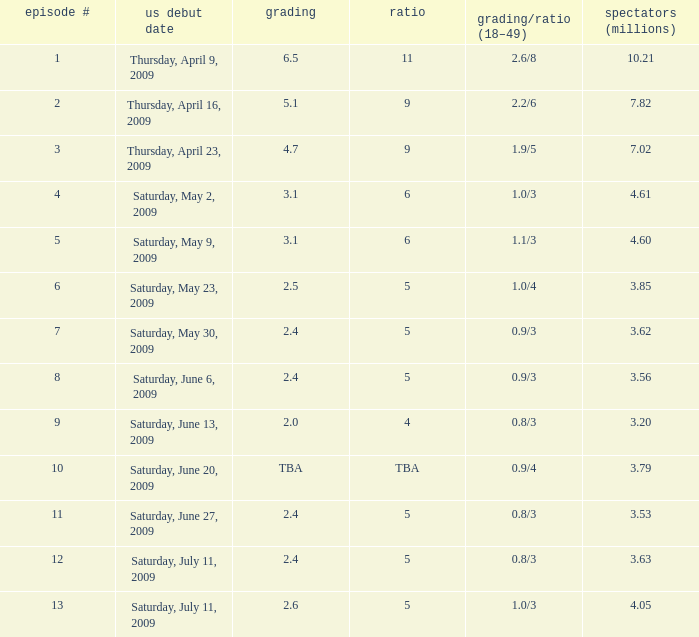Could you parse the entire table as a dict? {'header': ['episode #', 'us debut date', 'grading', 'ratio', 'grading/ratio (18–49)', 'spectators (millions)'], 'rows': [['1', 'Thursday, April 9, 2009', '6.5', '11', '2.6/8', '10.21'], ['2', 'Thursday, April 16, 2009', '5.1', '9', '2.2/6', '7.82'], ['3', 'Thursday, April 23, 2009', '4.7', '9', '1.9/5', '7.02'], ['4', 'Saturday, May 2, 2009', '3.1', '6', '1.0/3', '4.61'], ['5', 'Saturday, May 9, 2009', '3.1', '6', '1.1/3', '4.60'], ['6', 'Saturday, May 23, 2009', '2.5', '5', '1.0/4', '3.85'], ['7', 'Saturday, May 30, 2009', '2.4', '5', '0.9/3', '3.62'], ['8', 'Saturday, June 6, 2009', '2.4', '5', '0.9/3', '3.56'], ['9', 'Saturday, June 13, 2009', '2.0', '4', '0.8/3', '3.20'], ['10', 'Saturday, June 20, 2009', 'TBA', 'TBA', '0.9/4', '3.79'], ['11', 'Saturday, June 27, 2009', '2.4', '5', '0.8/3', '3.53'], ['12', 'Saturday, July 11, 2009', '2.4', '5', '0.8/3', '3.63'], ['13', 'Saturday, July 11, 2009', '2.6', '5', '1.0/3', '4.05']]} What is the rating/share for episode 13? 1.0/3. 